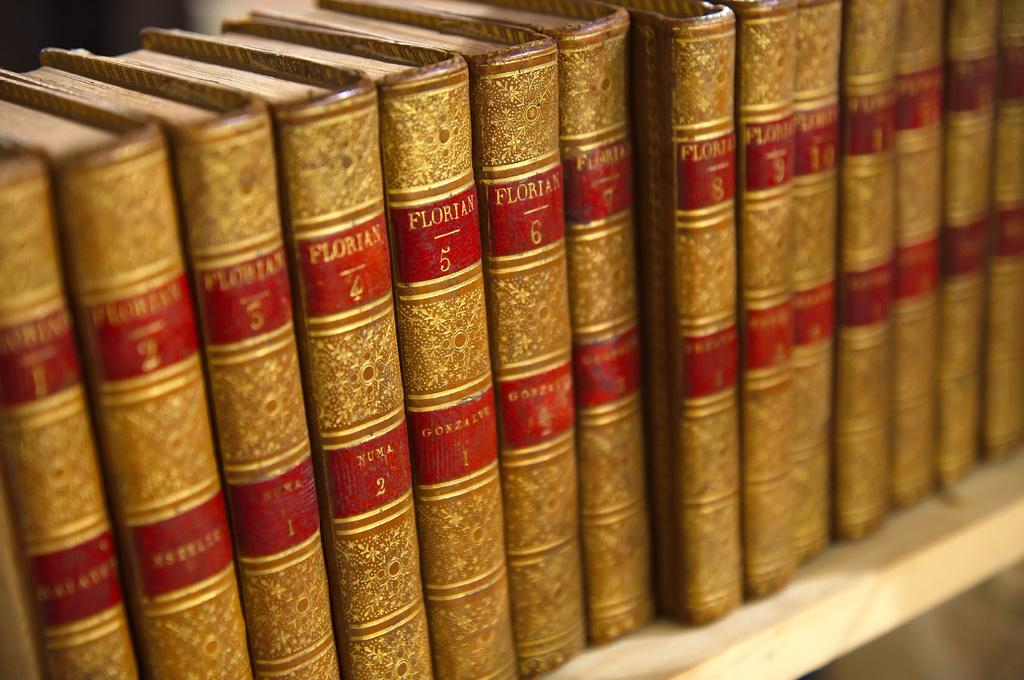Provide a one-sentence caption for the provided image. books that say 'floritan' with a number on the side of them. 